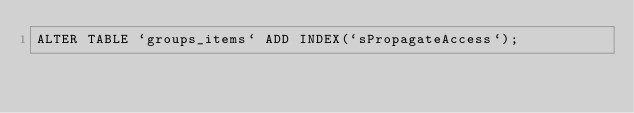Convert code to text. <code><loc_0><loc_0><loc_500><loc_500><_SQL_>ALTER TABLE `groups_items` ADD INDEX(`sPropagateAccess`);
</code> 